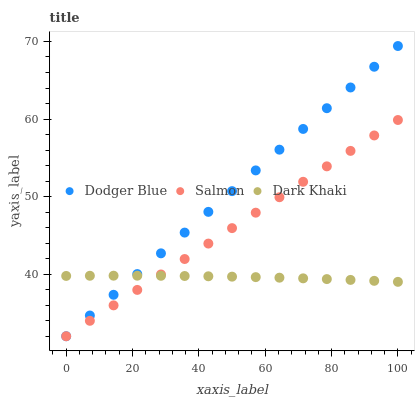Does Dark Khaki have the minimum area under the curve?
Answer yes or no. Yes. Does Dodger Blue have the maximum area under the curve?
Answer yes or no. Yes. Does Salmon have the minimum area under the curve?
Answer yes or no. No. Does Salmon have the maximum area under the curve?
Answer yes or no. No. Is Salmon the smoothest?
Answer yes or no. Yes. Is Dark Khaki the roughest?
Answer yes or no. Yes. Is Dodger Blue the smoothest?
Answer yes or no. No. Is Dodger Blue the roughest?
Answer yes or no. No. Does Salmon have the lowest value?
Answer yes or no. Yes. Does Dodger Blue have the highest value?
Answer yes or no. Yes. Does Salmon have the highest value?
Answer yes or no. No. Does Salmon intersect Dark Khaki?
Answer yes or no. Yes. Is Salmon less than Dark Khaki?
Answer yes or no. No. Is Salmon greater than Dark Khaki?
Answer yes or no. No. 